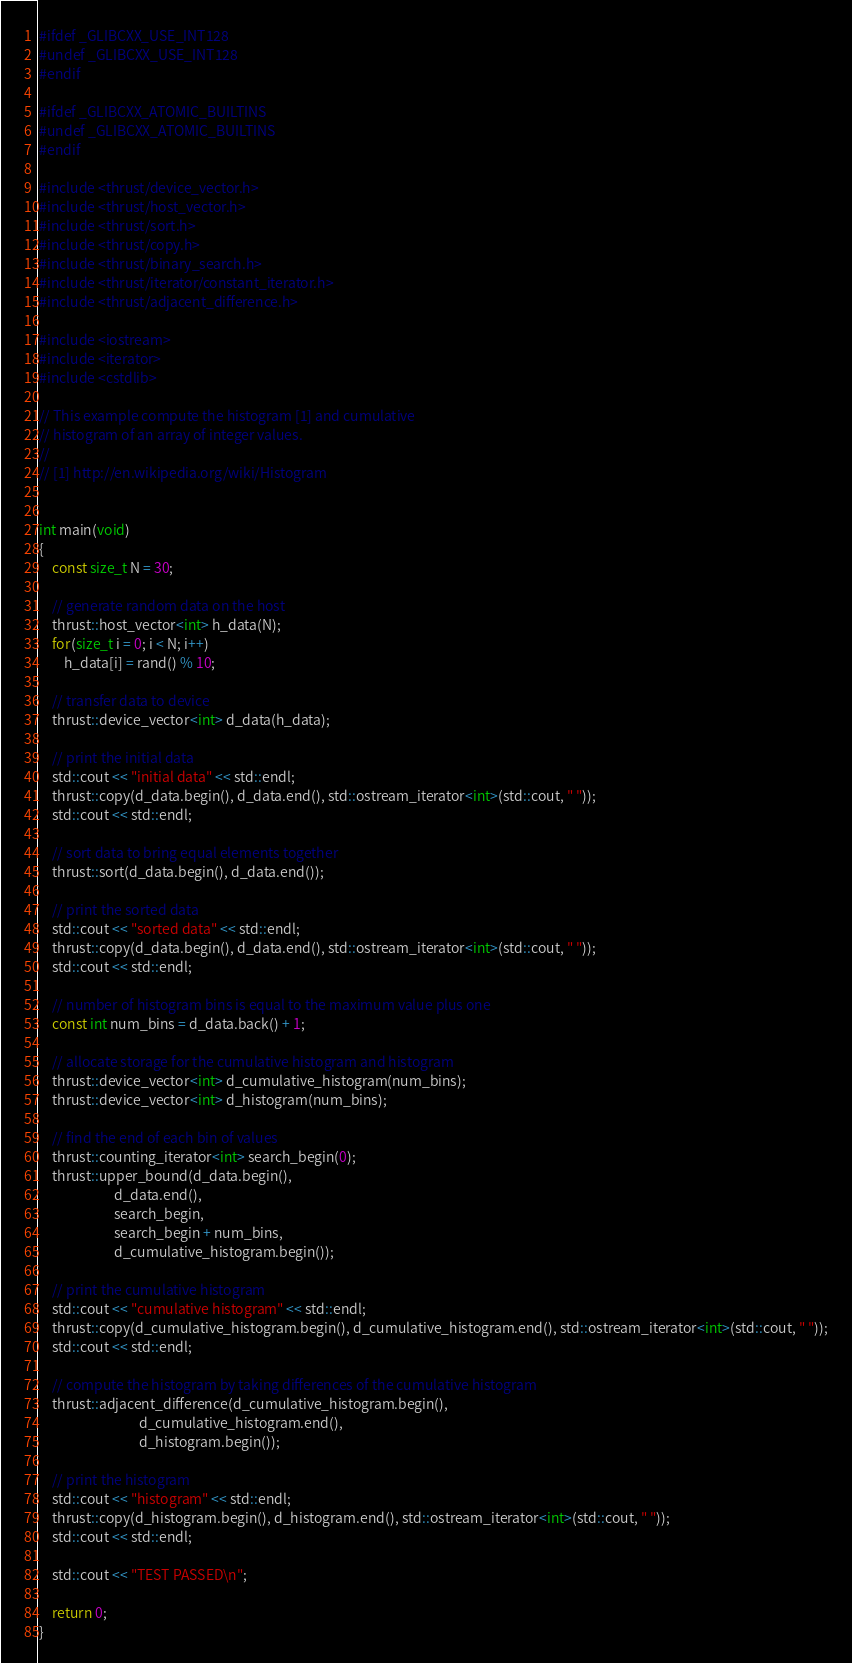Convert code to text. <code><loc_0><loc_0><loc_500><loc_500><_Cuda_>#ifdef _GLIBCXX_USE_INT128
#undef _GLIBCXX_USE_INT128
#endif 

#ifdef _GLIBCXX_ATOMIC_BUILTINS
#undef _GLIBCXX_ATOMIC_BUILTINS
#endif

#include <thrust/device_vector.h>
#include <thrust/host_vector.h>
#include <thrust/sort.h>
#include <thrust/copy.h>
#include <thrust/binary_search.h>
#include <thrust/iterator/constant_iterator.h>
#include <thrust/adjacent_difference.h>

#include <iostream>
#include <iterator>
#include <cstdlib>

// This example compute the histogram [1] and cumulative
// histogram of an array of integer values.
//
// [1] http://en.wikipedia.org/wiki/Histogram


int main(void)
{
    const size_t N = 30;

    // generate random data on the host
    thrust::host_vector<int> h_data(N);
    for(size_t i = 0; i < N; i++)
        h_data[i] = rand() % 10;

    // transfer data to device
    thrust::device_vector<int> d_data(h_data);
    
    // print the initial data
    std::cout << "initial data" << std::endl;
    thrust::copy(d_data.begin(), d_data.end(), std::ostream_iterator<int>(std::cout, " "));
    std::cout << std::endl;

    // sort data to bring equal elements together
    thrust::sort(d_data.begin(), d_data.end());
    
    // print the sorted data
    std::cout << "sorted data" << std::endl;
    thrust::copy(d_data.begin(), d_data.end(), std::ostream_iterator<int>(std::cout, " "));
    std::cout << std::endl;

    // number of histogram bins is equal to the maximum value plus one
    const int num_bins = d_data.back() + 1;

    // allocate storage for the cumulative histogram and histogram
    thrust::device_vector<int> d_cumulative_histogram(num_bins);
    thrust::device_vector<int> d_histogram(num_bins);
    
    // find the end of each bin of values
    thrust::counting_iterator<int> search_begin(0);
    thrust::upper_bound(d_data.begin(),
                        d_data.end(),
                        search_begin,
                        search_begin + num_bins,
                        d_cumulative_histogram.begin());
    
    // print the cumulative histogram
    std::cout << "cumulative histogram" << std::endl;
    thrust::copy(d_cumulative_histogram.begin(), d_cumulative_histogram.end(), std::ostream_iterator<int>(std::cout, " "));
    std::cout << std::endl;

    // compute the histogram by taking differences of the cumulative histogram
    thrust::adjacent_difference(d_cumulative_histogram.begin(),
                                d_cumulative_histogram.end(),
                                d_histogram.begin());

    // print the histogram
    std::cout << "histogram" << std::endl;
    thrust::copy(d_histogram.begin(), d_histogram.end(), std::ostream_iterator<int>(std::cout, " "));
    std::cout << std::endl;
    
    std::cout << "TEST PASSED\n";
    
    return 0;
}

</code> 